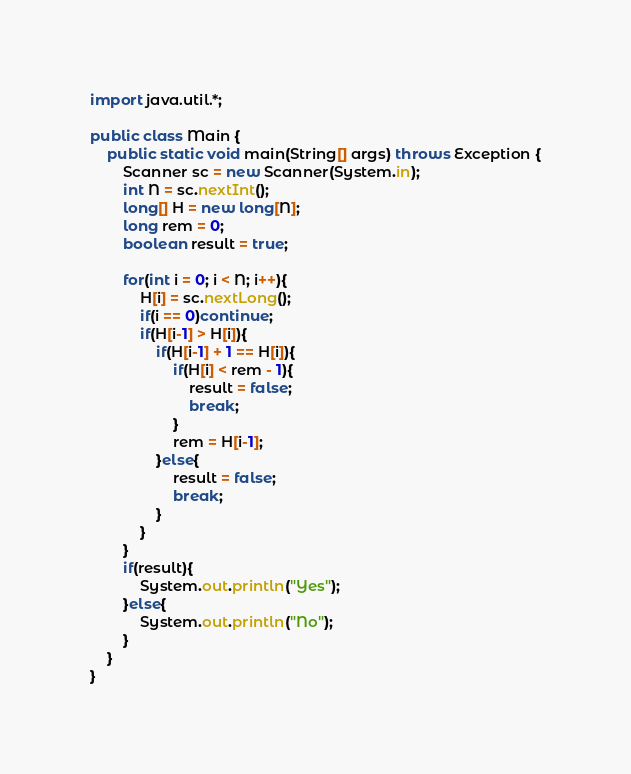<code> <loc_0><loc_0><loc_500><loc_500><_Java_>import java.util.*;

public class Main {
    public static void main(String[] args) throws Exception {
        Scanner sc = new Scanner(System.in);
        int N = sc.nextInt();
        long[] H = new long[N];
        long rem = 0;
        boolean result = true;
        
        for(int i = 0; i < N; i++){
            H[i] = sc.nextLong();
            if(i == 0)continue;
            if(H[i-1] > H[i]){
                if(H[i-1] + 1 == H[i]){
                    if(H[i] < rem - 1){
                        result = false;
                        break;
                    }
                    rem = H[i-1];
                }else{
                    result = false;
                    break;
                }
            }
        }
        if(result){
            System.out.println("Yes");
        }else{
            System.out.println("No");
        }
    }
}
</code> 